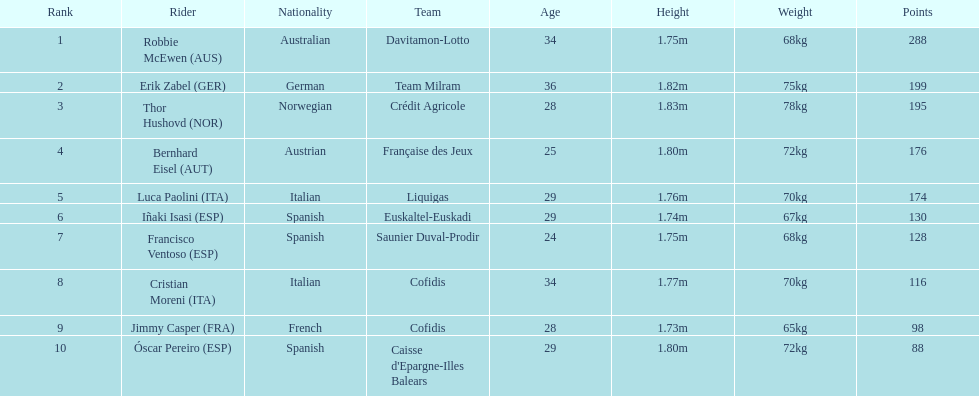How many points did robbie mcewen and cristian moreni score together? 404. 